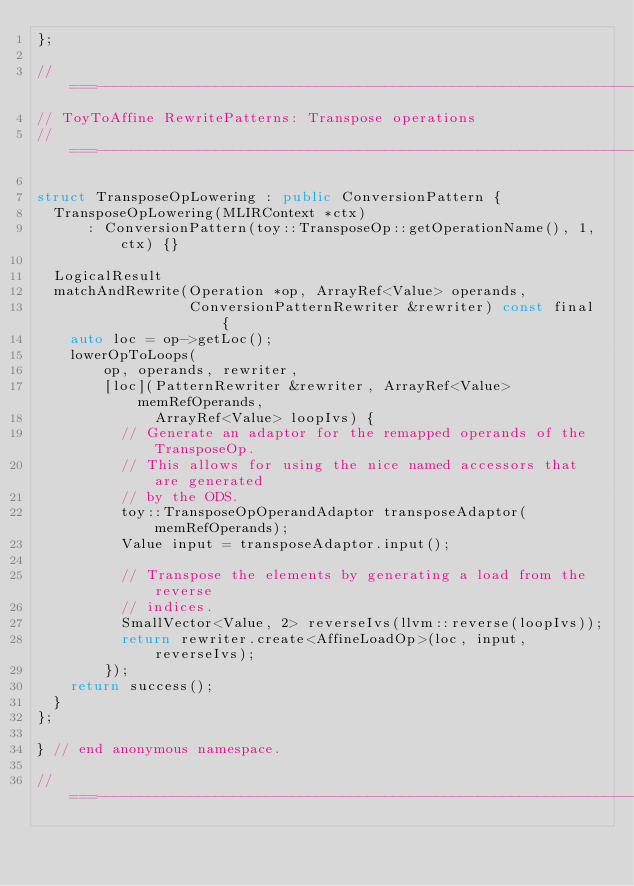Convert code to text. <code><loc_0><loc_0><loc_500><loc_500><_C++_>};

//===----------------------------------------------------------------------===//
// ToyToAffine RewritePatterns: Transpose operations
//===----------------------------------------------------------------------===//

struct TransposeOpLowering : public ConversionPattern {
  TransposeOpLowering(MLIRContext *ctx)
      : ConversionPattern(toy::TransposeOp::getOperationName(), 1, ctx) {}

  LogicalResult
  matchAndRewrite(Operation *op, ArrayRef<Value> operands,
                  ConversionPatternRewriter &rewriter) const final {
    auto loc = op->getLoc();
    lowerOpToLoops(
        op, operands, rewriter,
        [loc](PatternRewriter &rewriter, ArrayRef<Value> memRefOperands,
              ArrayRef<Value> loopIvs) {
          // Generate an adaptor for the remapped operands of the TransposeOp.
          // This allows for using the nice named accessors that are generated
          // by the ODS.
          toy::TransposeOpOperandAdaptor transposeAdaptor(memRefOperands);
          Value input = transposeAdaptor.input();

          // Transpose the elements by generating a load from the reverse
          // indices.
          SmallVector<Value, 2> reverseIvs(llvm::reverse(loopIvs));
          return rewriter.create<AffineLoadOp>(loc, input, reverseIvs);
        });
    return success();
  }
};

} // end anonymous namespace.

//===----------------------------------------------------------------------===//</code> 